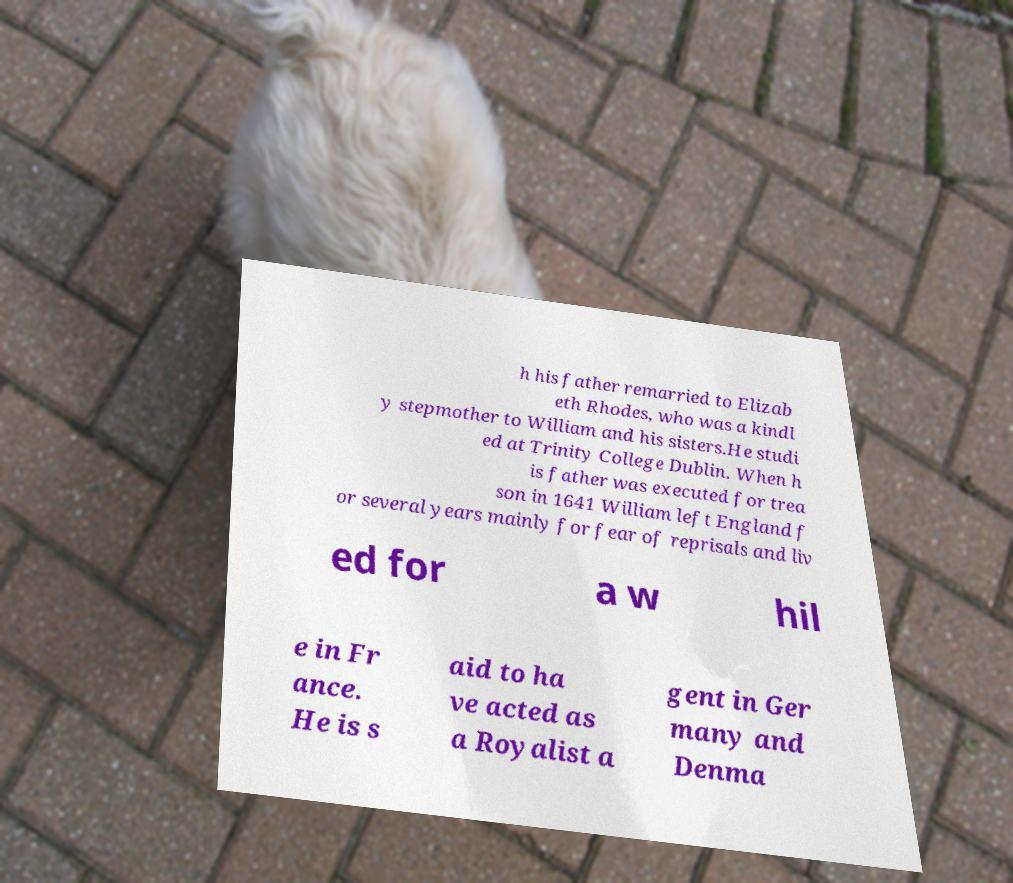I need the written content from this picture converted into text. Can you do that? h his father remarried to Elizab eth Rhodes, who was a kindl y stepmother to William and his sisters.He studi ed at Trinity College Dublin. When h is father was executed for trea son in 1641 William left England f or several years mainly for fear of reprisals and liv ed for a w hil e in Fr ance. He is s aid to ha ve acted as a Royalist a gent in Ger many and Denma 